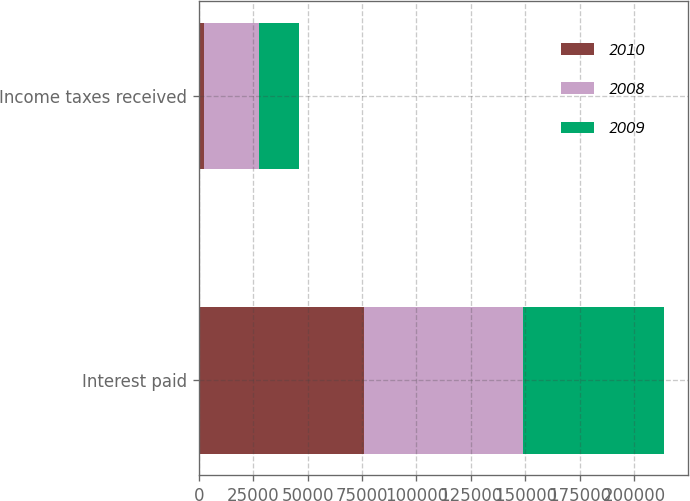Convert chart to OTSL. <chart><loc_0><loc_0><loc_500><loc_500><stacked_bar_chart><ecel><fcel>Interest paid<fcel>Income taxes received<nl><fcel>2010<fcel>75909<fcel>2379<nl><fcel>2008<fcel>73031<fcel>25202<nl><fcel>2009<fcel>64997<fcel>18351<nl></chart> 